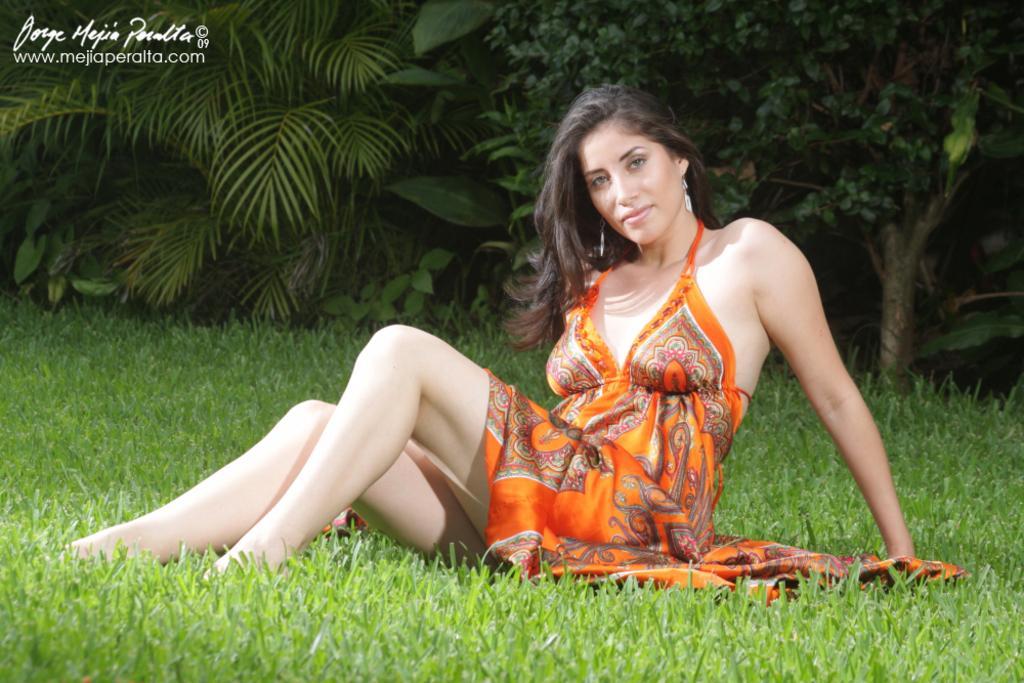Can you describe this image briefly? In this image we can see a lady is wearing orange color dress and sitting on the grass and maybe she is giving a pose to a photograph. In the background of the image we can see trees. 